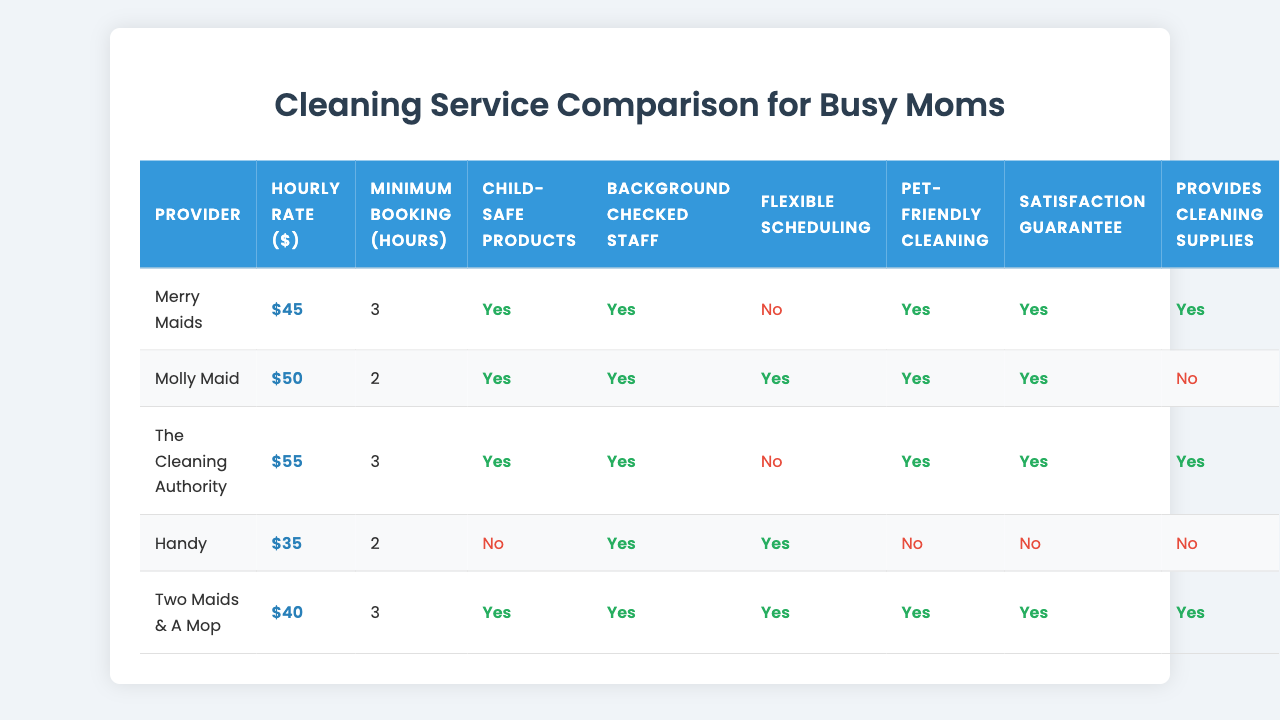What is the hourly rate for Handy? In the table, the hourly rate for Handy is listed as $35.
Answer: $35 Which cleaning service provider has the highest hourly rate? By comparing the hourly rates in the table, The Cleaning Authority has the highest rate at $55.
Answer: The Cleaning Authority Does Merry Maids provide child-safe products? According to the table, Merry Maids is marked as providing child-safe products (true).
Answer: Yes How many providers allow flexible scheduling? By reviewing the table, Handy and Molly Maid both offer flexible scheduling, totaling two providers.
Answer: Two Which provider has the lowest minimum booking time? The minimum booking time for Handy and Molly Maid is 2 hours, which is the lowest compared to others.
Answer: Handy and Molly Maid How much more expensive is The Cleaning Authority compared to Merry Maids? The Cleaning Authority charges $55 while Merry Maids charges $45, so the difference is $55 - $45 = $10.
Answer: $10 Do Two Maids & A Mop and Handy both offer pet-friendly cleaning? Reviewing the table, only Two Maids & A Mop provides pet-friendly cleaning. Handy does not offer this feature.
Answer: No What is the average hourly rate of the cleaning services in the table? The hourly rates are $45, $50, $55, $35, and $40. The sum is $225, and when divided by 5 providers, the average is $225 / 5 = $45.
Answer: $45 Which cleaning service providers have background-checked staff? Checking the table, all providers except Handy have background-checked staff. Thus, four providers have this feature.
Answer: Four If I prefer a service with a satisfaction guarantee and child-safe products, which providers can I choose? The providers that offer both features are Merry Maids, Molly Maid, and The Cleaning Authority, totaling three options.
Answer: Three 